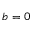<formula> <loc_0><loc_0><loc_500><loc_500>b = 0</formula> 